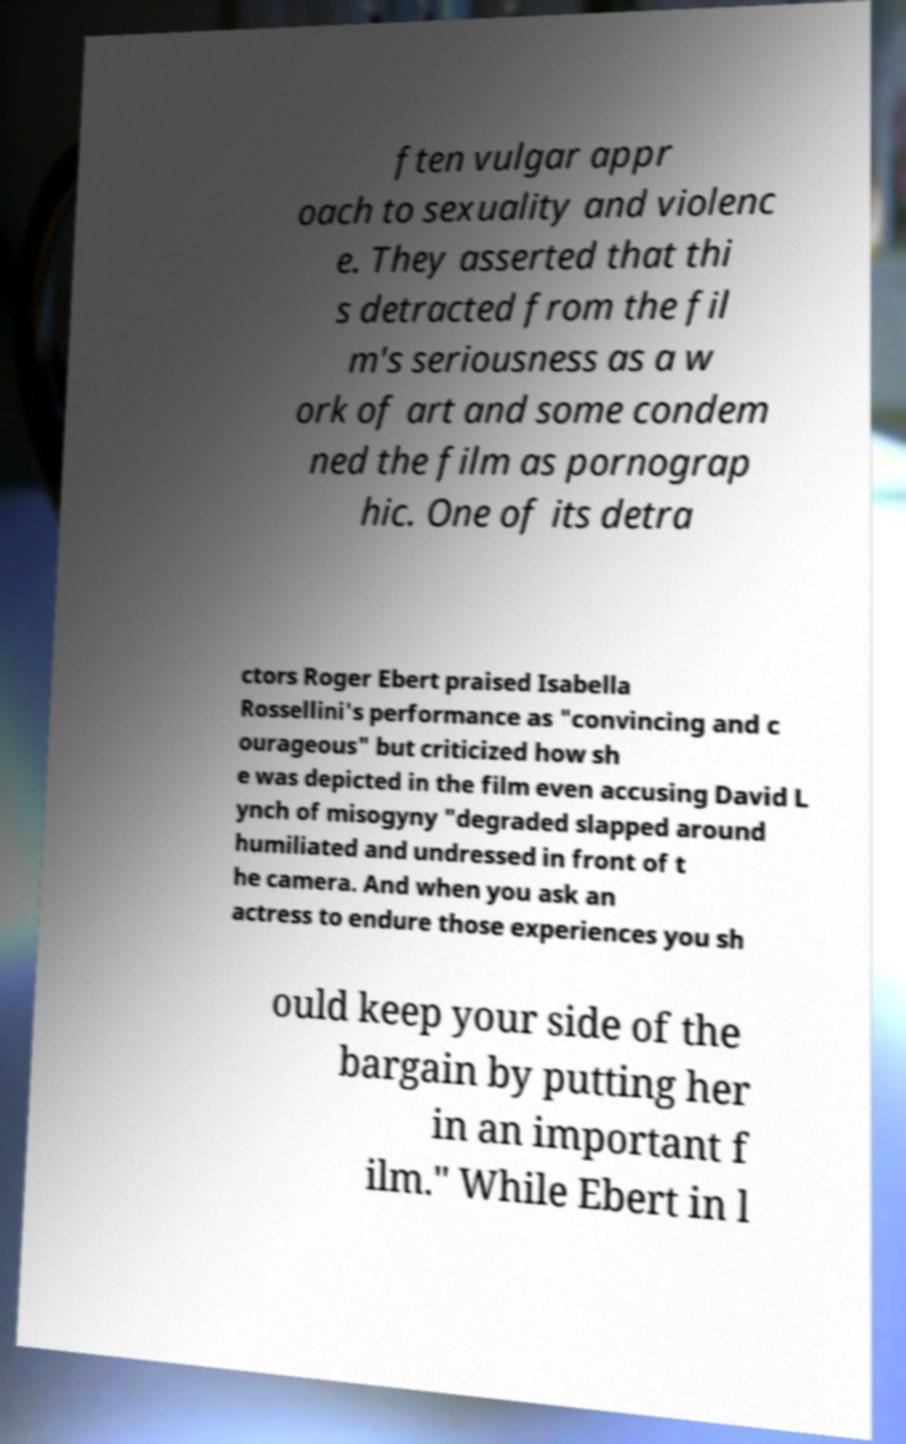There's text embedded in this image that I need extracted. Can you transcribe it verbatim? ften vulgar appr oach to sexuality and violenc e. They asserted that thi s detracted from the fil m's seriousness as a w ork of art and some condem ned the film as pornograp hic. One of its detra ctors Roger Ebert praised Isabella Rossellini's performance as "convincing and c ourageous" but criticized how sh e was depicted in the film even accusing David L ynch of misogyny "degraded slapped around humiliated and undressed in front of t he camera. And when you ask an actress to endure those experiences you sh ould keep your side of the bargain by putting her in an important f ilm." While Ebert in l 